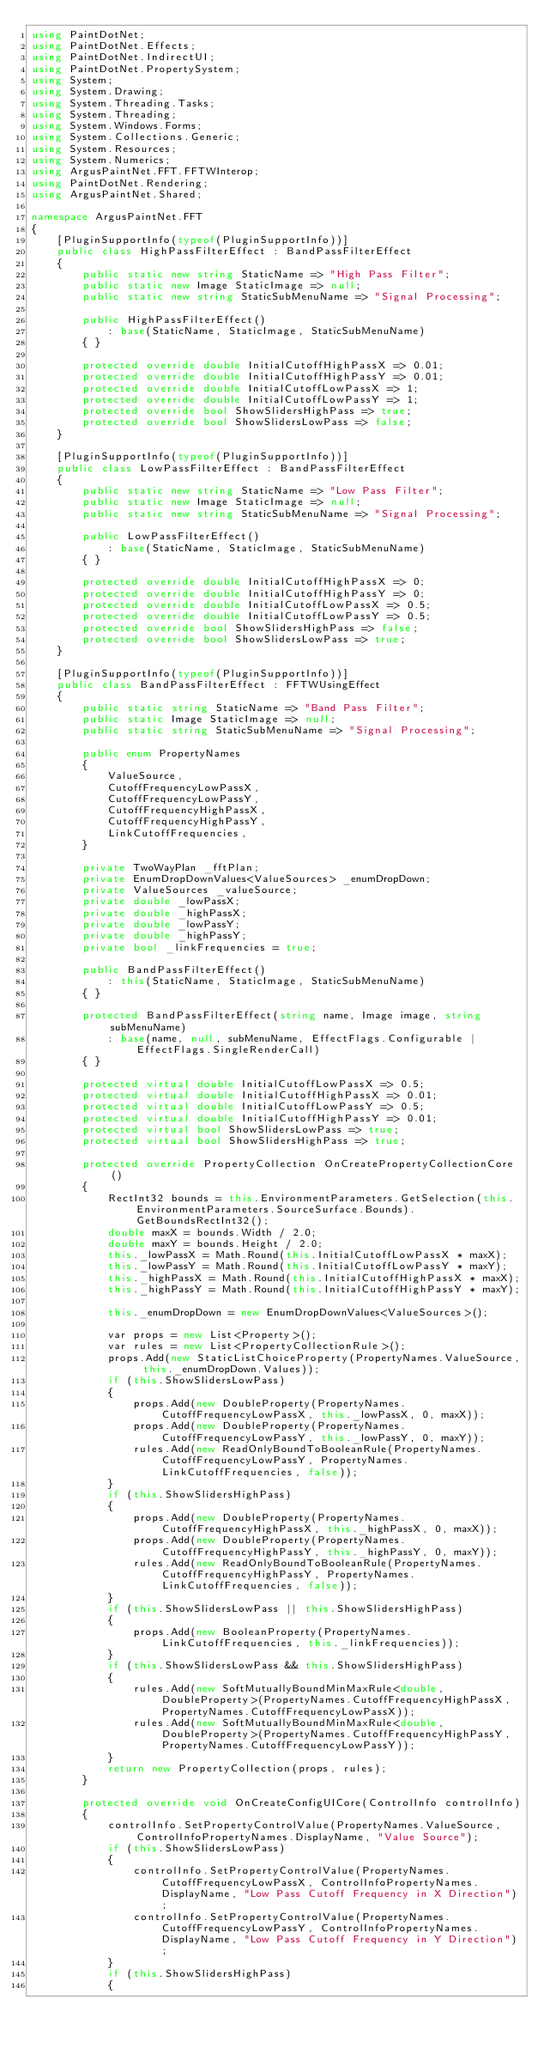Convert code to text. <code><loc_0><loc_0><loc_500><loc_500><_C#_>using PaintDotNet;
using PaintDotNet.Effects;
using PaintDotNet.IndirectUI;
using PaintDotNet.PropertySystem;
using System;
using System.Drawing;
using System.Threading.Tasks;
using System.Threading;
using System.Windows.Forms;
using System.Collections.Generic;
using System.Resources;
using System.Numerics;
using ArgusPaintNet.FFT.FFTWInterop;
using PaintDotNet.Rendering;
using ArgusPaintNet.Shared;

namespace ArgusPaintNet.FFT
{
    [PluginSupportInfo(typeof(PluginSupportInfo))]
    public class HighPassFilterEffect : BandPassFilterEffect
    {
        public static new string StaticName => "High Pass Filter";
        public static new Image StaticImage => null;
        public static new string StaticSubMenuName => "Signal Processing";

        public HighPassFilterEffect()
            : base(StaticName, StaticImage, StaticSubMenuName)
        { }

        protected override double InitialCutoffHighPassX => 0.01;
        protected override double InitialCutoffHighPassY => 0.01;
        protected override double InitialCutoffLowPassX => 1;
        protected override double InitialCutoffLowPassY => 1;
        protected override bool ShowSlidersHighPass => true;
        protected override bool ShowSlidersLowPass => false;
    }

    [PluginSupportInfo(typeof(PluginSupportInfo))]
    public class LowPassFilterEffect : BandPassFilterEffect
    {
        public static new string StaticName => "Low Pass Filter";
        public static new Image StaticImage => null;
        public static new string StaticSubMenuName => "Signal Processing";

        public LowPassFilterEffect()
            : base(StaticName, StaticImage, StaticSubMenuName)
        { }

        protected override double InitialCutoffHighPassX => 0;
        protected override double InitialCutoffHighPassY => 0;
        protected override double InitialCutoffLowPassX => 0.5;
        protected override double InitialCutoffLowPassY => 0.5;
        protected override bool ShowSlidersHighPass => false;
        protected override bool ShowSlidersLowPass => true;
    }

    [PluginSupportInfo(typeof(PluginSupportInfo))]
    public class BandPassFilterEffect : FFTWUsingEffect
    {
        public static string StaticName => "Band Pass Filter";
        public static Image StaticImage => null;
        public static string StaticSubMenuName => "Signal Processing";

        public enum PropertyNames
        {
            ValueSource,
            CutoffFrequencyLowPassX,
            CutoffFrequencyLowPassY,
            CutoffFrequencyHighPassX,
            CutoffFrequencyHighPassY,
            LinkCutoffFrequencies,
        }

        private TwoWayPlan _fftPlan;
        private EnumDropDownValues<ValueSources> _enumDropDown;
        private ValueSources _valueSource;
        private double _lowPassX;
        private double _highPassX;
        private double _lowPassY;
        private double _highPassY;
        private bool _linkFrequencies = true;

        public BandPassFilterEffect()
            : this(StaticName, StaticImage, StaticSubMenuName)
        { }

        protected BandPassFilterEffect(string name, Image image, string subMenuName)
            : base(name, null, subMenuName, EffectFlags.Configurable | EffectFlags.SingleRenderCall)
        { }

        protected virtual double InitialCutoffLowPassX => 0.5;
        protected virtual double InitialCutoffHighPassX => 0.01;
        protected virtual double InitialCutoffLowPassY => 0.5;
        protected virtual double InitialCutoffHighPassY => 0.01;
        protected virtual bool ShowSlidersLowPass => true;
        protected virtual bool ShowSlidersHighPass => true;

        protected override PropertyCollection OnCreatePropertyCollectionCore()
        {
            RectInt32 bounds = this.EnvironmentParameters.GetSelection(this.EnvironmentParameters.SourceSurface.Bounds).GetBoundsRectInt32();
            double maxX = bounds.Width / 2.0;
            double maxY = bounds.Height / 2.0;
            this._lowPassX = Math.Round(this.InitialCutoffLowPassX * maxX);
            this._lowPassY = Math.Round(this.InitialCutoffLowPassY * maxY);
            this._highPassX = Math.Round(this.InitialCutoffHighPassX * maxX);
            this._highPassY = Math.Round(this.InitialCutoffHighPassY * maxY);

            this._enumDropDown = new EnumDropDownValues<ValueSources>();

            var props = new List<Property>();
            var rules = new List<PropertyCollectionRule>();
            props.Add(new StaticListChoiceProperty(PropertyNames.ValueSource, this._enumDropDown.Values));
            if (this.ShowSlidersLowPass)
            {
                props.Add(new DoubleProperty(PropertyNames.CutoffFrequencyLowPassX, this._lowPassX, 0, maxX));
                props.Add(new DoubleProperty(PropertyNames.CutoffFrequencyLowPassY, this._lowPassY, 0, maxY));
                rules.Add(new ReadOnlyBoundToBooleanRule(PropertyNames.CutoffFrequencyLowPassY, PropertyNames.LinkCutoffFrequencies, false));
            }
            if (this.ShowSlidersHighPass)
            {
                props.Add(new DoubleProperty(PropertyNames.CutoffFrequencyHighPassX, this._highPassX, 0, maxX));
                props.Add(new DoubleProperty(PropertyNames.CutoffFrequencyHighPassY, this._highPassY, 0, maxY));
                rules.Add(new ReadOnlyBoundToBooleanRule(PropertyNames.CutoffFrequencyHighPassY, PropertyNames.LinkCutoffFrequencies, false));
            }
            if (this.ShowSlidersLowPass || this.ShowSlidersHighPass)
            {
                props.Add(new BooleanProperty(PropertyNames.LinkCutoffFrequencies, this._linkFrequencies));
            }
            if (this.ShowSlidersLowPass && this.ShowSlidersHighPass)
            {
                rules.Add(new SoftMutuallyBoundMinMaxRule<double, DoubleProperty>(PropertyNames.CutoffFrequencyHighPassX, PropertyNames.CutoffFrequencyLowPassX));
                rules.Add(new SoftMutuallyBoundMinMaxRule<double, DoubleProperty>(PropertyNames.CutoffFrequencyHighPassY, PropertyNames.CutoffFrequencyLowPassY));
            }
            return new PropertyCollection(props, rules);
        }

        protected override void OnCreateConfigUICore(ControlInfo controlInfo)
        {
            controlInfo.SetPropertyControlValue(PropertyNames.ValueSource, ControlInfoPropertyNames.DisplayName, "Value Source");
            if (this.ShowSlidersLowPass)
            {
                controlInfo.SetPropertyControlValue(PropertyNames.CutoffFrequencyLowPassX, ControlInfoPropertyNames.DisplayName, "Low Pass Cutoff Frequency in X Direction");
                controlInfo.SetPropertyControlValue(PropertyNames.CutoffFrequencyLowPassY, ControlInfoPropertyNames.DisplayName, "Low Pass Cutoff Frequency in Y Direction");
            }
            if (this.ShowSlidersHighPass)
            {</code> 